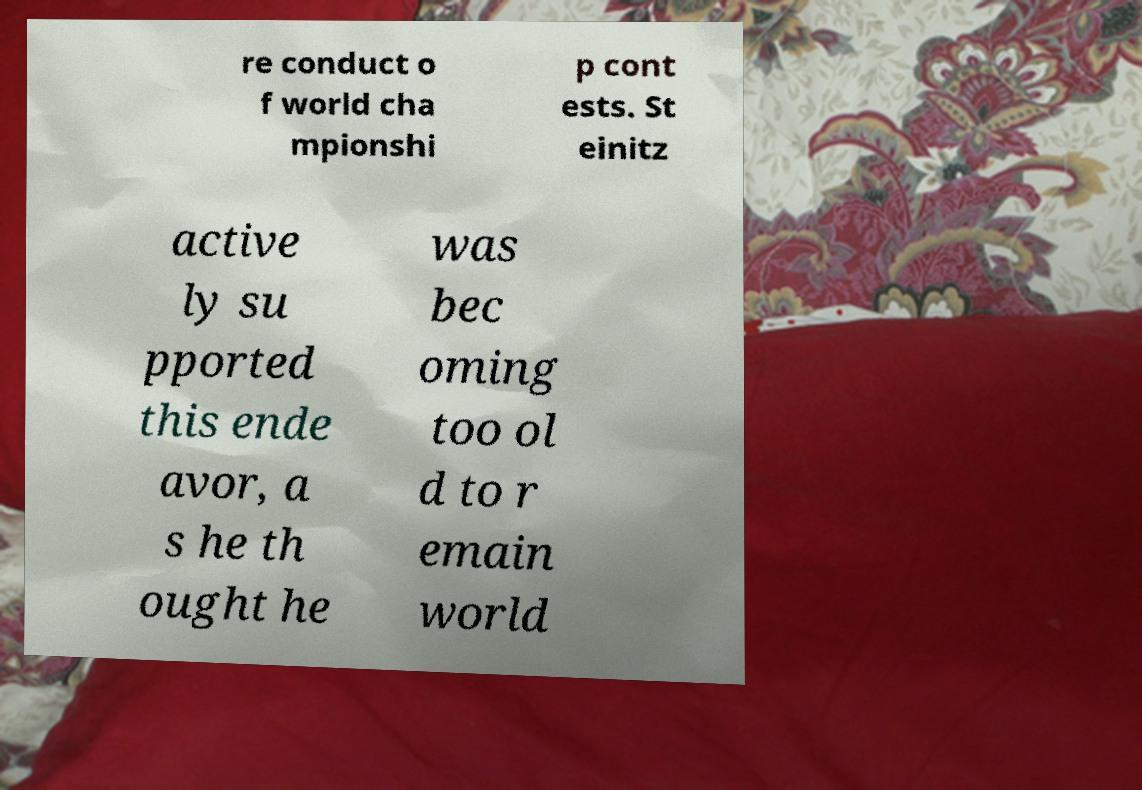Please identify and transcribe the text found in this image. re conduct o f world cha mpionshi p cont ests. St einitz active ly su pported this ende avor, a s he th ought he was bec oming too ol d to r emain world 